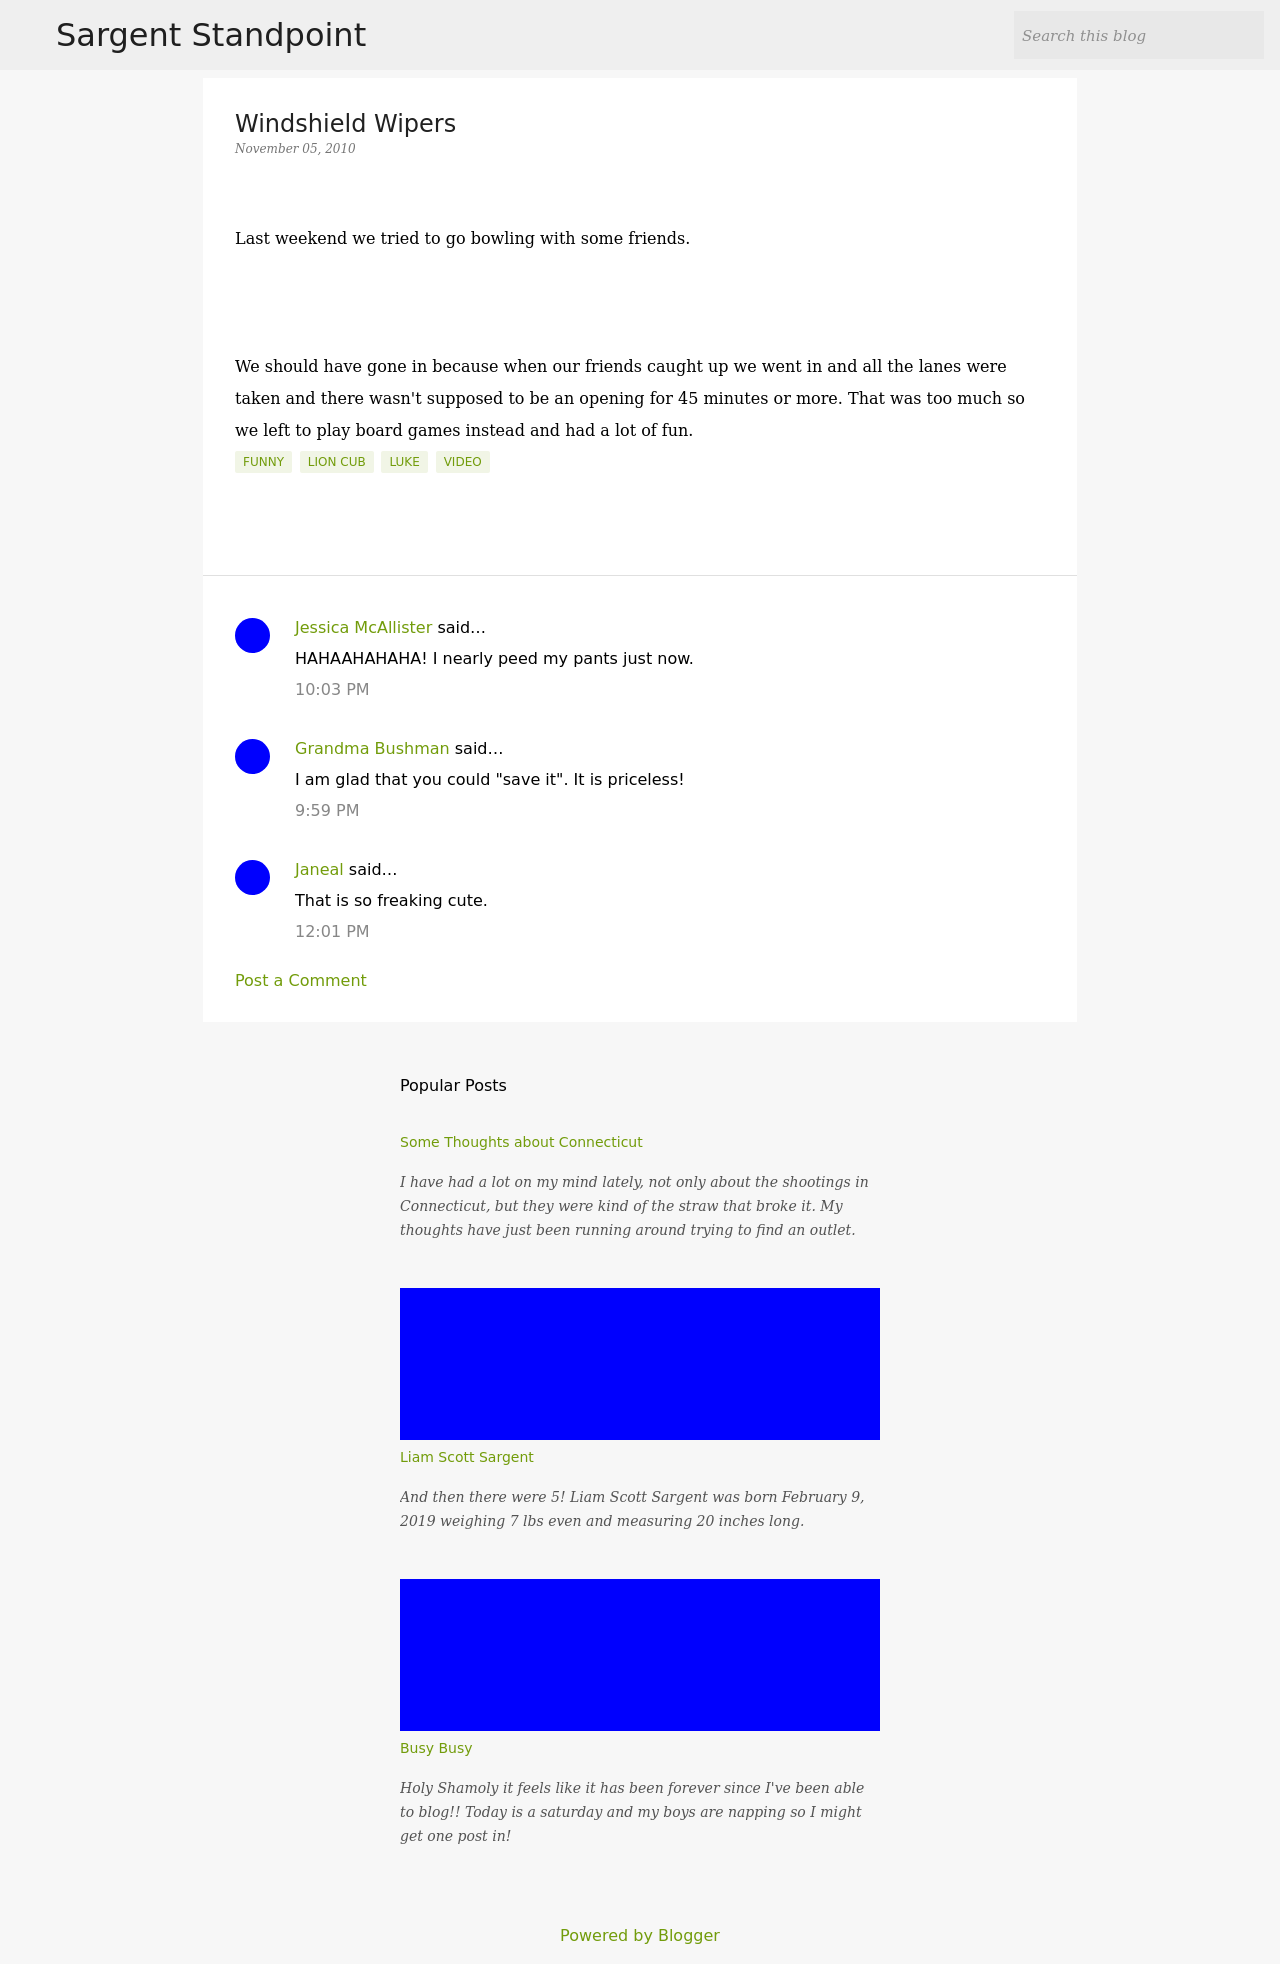Are there any comments mentioned in the blog post, and what was the general reaction? Yes, there are comments on the blog post. One user commented how funny the story was, conveying laughter, while another expressed appreciation for the decision the group made, highlighting the spontaneity and fun in the change of plans. The general response is positive, finding humor and joy in the shared story. 